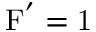<formula> <loc_0><loc_0><loc_500><loc_500>F ^ { ^ { \prime } } = 1</formula> 